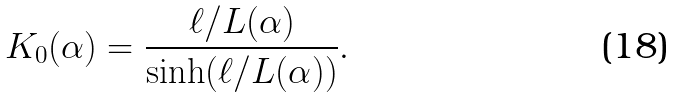Convert formula to latex. <formula><loc_0><loc_0><loc_500><loc_500>K _ { 0 } ( \alpha ) = \frac { \ell / L ( \alpha ) } { \sinh ( \ell / L ( \alpha ) ) } .</formula> 